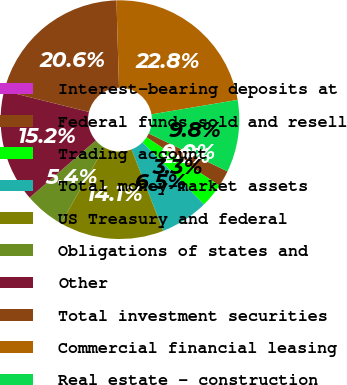<chart> <loc_0><loc_0><loc_500><loc_500><pie_chart><fcel>Interest-bearing deposits at<fcel>Federal funds sold and resell<fcel>Trading account<fcel>Total money-market assets<fcel>US Treasury and federal<fcel>Obligations of states and<fcel>Other<fcel>Total investment securities<fcel>Commercial financial leasing<fcel>Real estate - construction<nl><fcel>0.0%<fcel>2.18%<fcel>3.26%<fcel>6.52%<fcel>14.13%<fcel>5.44%<fcel>15.22%<fcel>20.65%<fcel>22.82%<fcel>9.78%<nl></chart> 